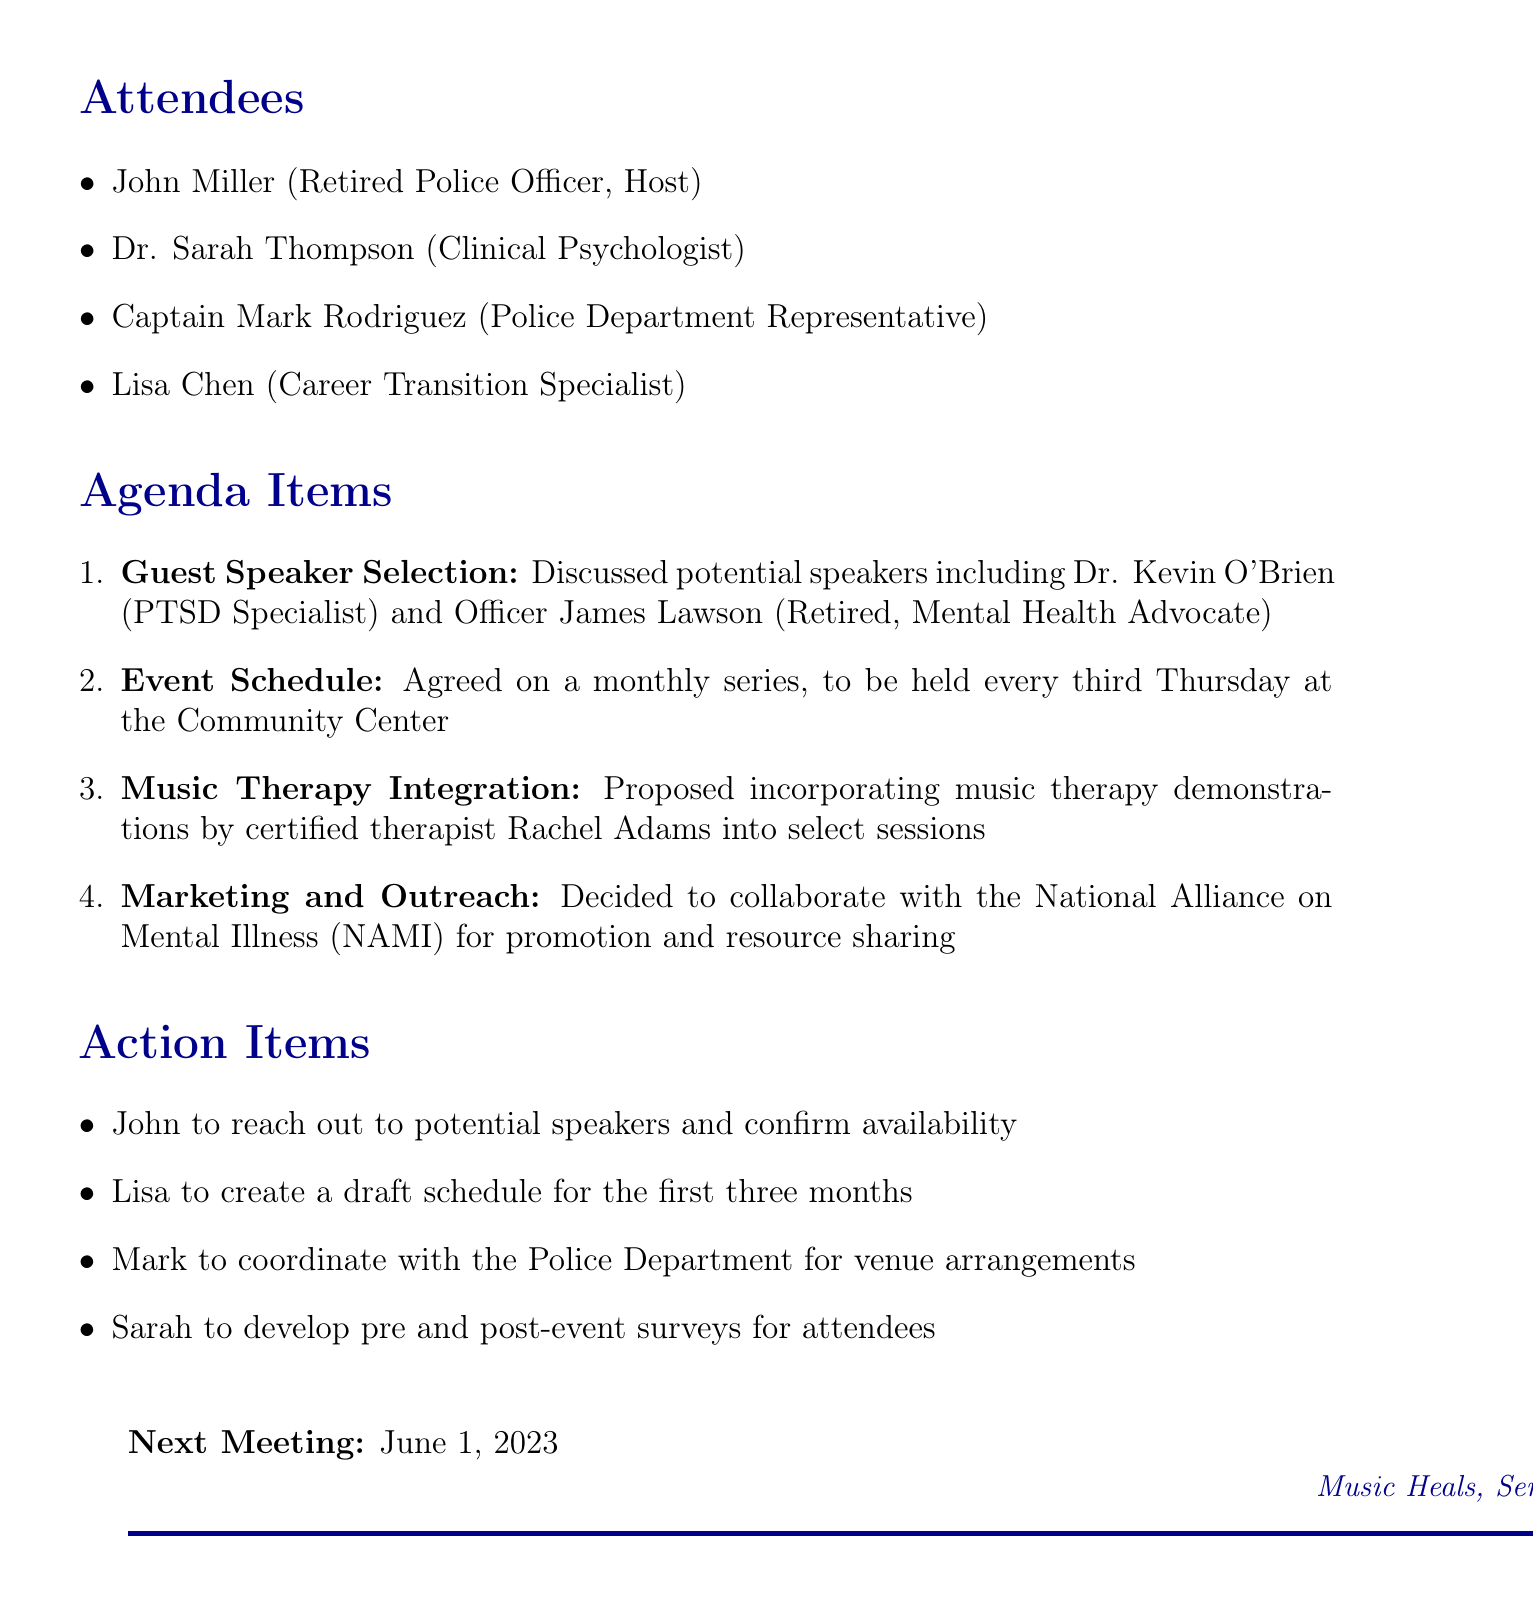What is the meeting title? The meeting title is provided in the document as the first line under the meeting minutes section.
Answer: Coordination of Guest Speaker Series on Law Enforcement Career Transitions and Mental Health Awareness Who hosted the meeting? The document lists the attendees and identifies John Miller as the host of the meeting.
Answer: John Miller What date was the meeting held? The meeting date is clearly mentioned in the document under the meeting title section.
Answer: May 15, 2023 How often will the guest speaker series be held? The document states that the series will occur monthly, specifically every third Thursday.
Answer: Monthly Who is proposed to demonstrate music therapy? The agenda item on music therapy integration specifies a certified therapist planned for demonstrations.
Answer: Rachel Adams What is the role of Lisa Chen? Lisa Chen's title is given in the list of attendees, clarifying her function in the meeting.
Answer: Career Transition Specialist What is one action item assigned to John? The action items section lists who is responsible for specific tasks stemming from the meeting discussions.
Answer: Reach out to potential speakers and confirm availability Which organization will be collaborated with for marketing? The marketing and outreach agenda item mentions collaborating with a specific organization.
Answer: National Alliance on Mental Illness (NAMI) What is the date of the next meeting? The document contains a section indicating when the next meeting will be held.
Answer: June 1, 2023 